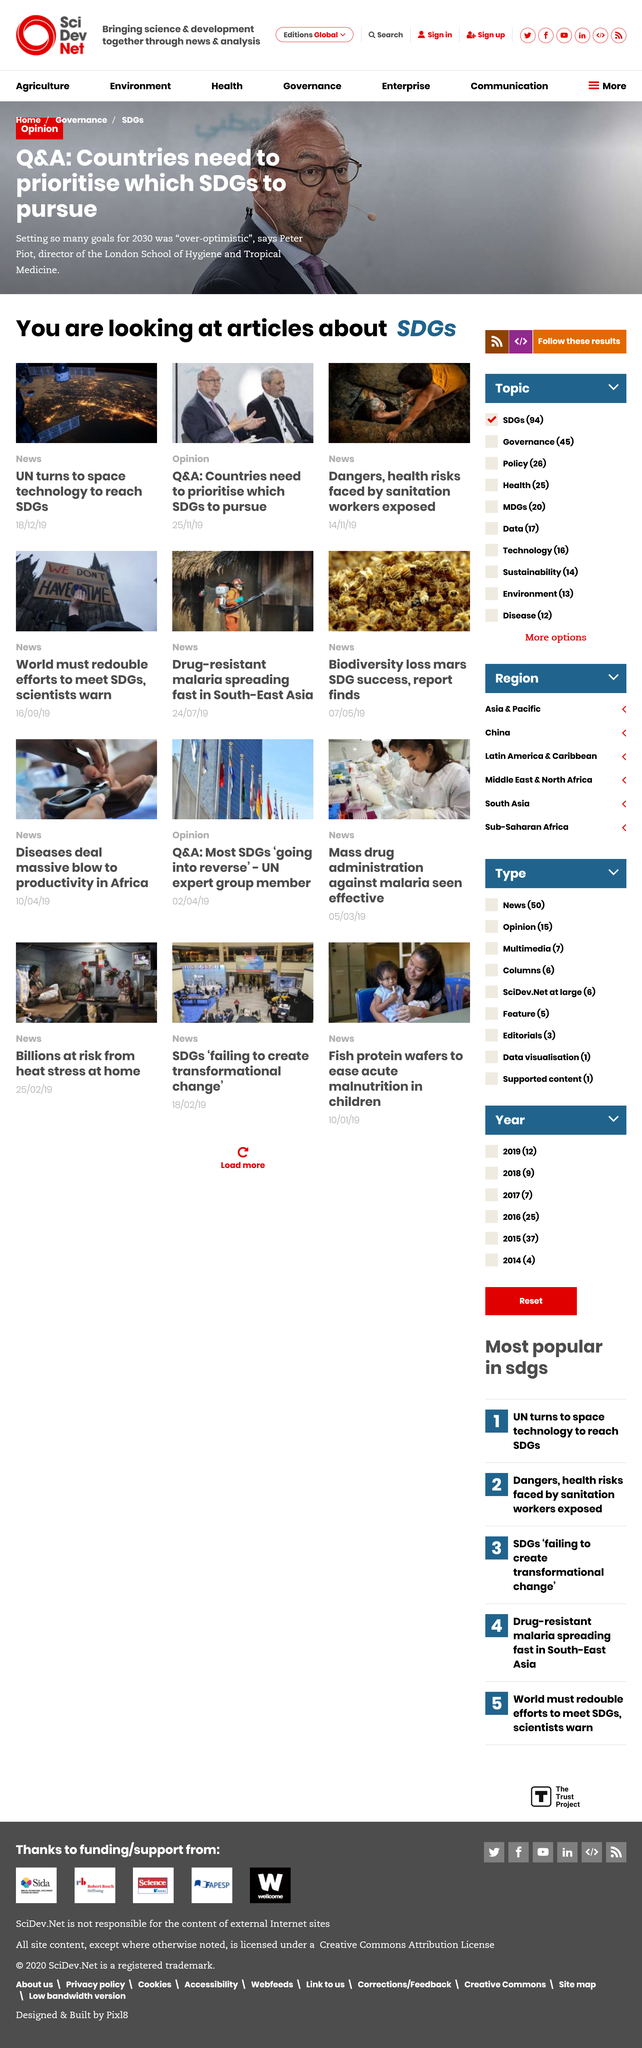Draw attention to some important aspects in this diagram. Sanitation workers are routinely exposed to dangers and health risks due to the hazardous nature of their work. It is overly optimistic to set too many goals for 2030 on this page. The Q&A is with Peter Piot, the director of the London School of Hygiene and Tropical Medicine. 